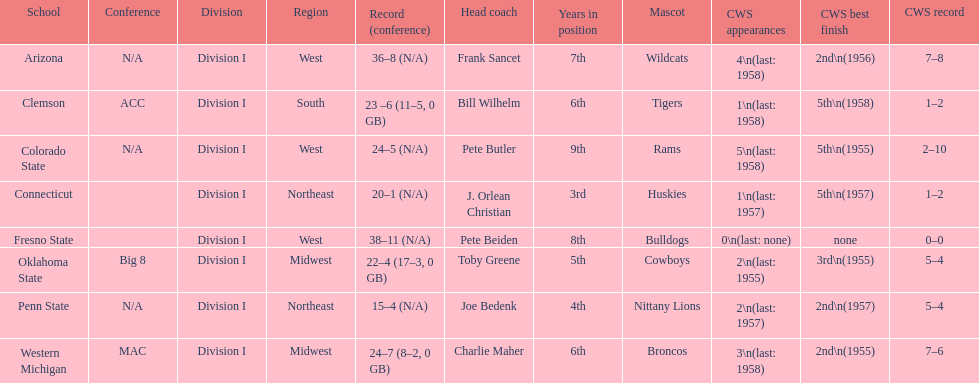Could you parse the entire table? {'header': ['School', 'Conference', 'Division', 'Region', 'Record (conference)', 'Head coach', 'Years in position', 'Mascot', 'CWS appearances', 'CWS best finish', 'CWS record'], 'rows': [['Arizona', 'N/A', 'Division I', 'West', '36–8 (N/A)', 'Frank Sancet', '7th', 'Wildcats', '4\\n(last: 1958)', '2nd\\n(1956)', '7–8'], ['Clemson', 'ACC', 'Division I', 'South', '23 –6 (11–5, 0 GB)', 'Bill Wilhelm', '6th', 'Tigers', '1\\n(last: 1958)', '5th\\n(1958)', '1–2'], ['Colorado State', 'N/A', 'Division I', 'West', '24–5 (N/A)', 'Pete Butler', '9th', 'Rams', '5\\n(last: 1958)', '5th\\n(1955)', '2–10'], ['Connecticut', '', 'Division I', 'Northeast', '20–1 (N/A)', 'J. Orlean Christian', '3rd', 'Huskies', '1\\n(last: 1957)', '5th\\n(1957)', '1–2'], ['Fresno State', '', 'Division I', 'West', '38–11 (N/A)', 'Pete Beiden', '8th', 'Bulldogs', '0\\n(last: none)', 'none', '0–0'], ['Oklahoma State', 'Big 8', 'Division I', 'Midwest', '22–4 (17–3, 0 GB)', 'Toby Greene', '5th', 'Cowboys', '2\\n(last: 1955)', '3rd\\n(1955)', '5–4'], ['Penn State', 'N/A', 'Division I', 'Northeast', '15–4 (N/A)', 'Joe Bedenk', '4th', 'Nittany Lions', '2\\n(last: 1957)', '2nd\\n(1957)', '5–4'], ['Western Michigan', 'MAC', 'Division I', 'Midwest', '24–7 (8–2, 0 GB)', 'Charlie Maher', '6th', 'Broncos', '3\\n(last: 1958)', '2nd\\n(1955)', '7–6']]} List each of the schools that came in 2nd for cws best finish. Arizona, Penn State, Western Michigan. 